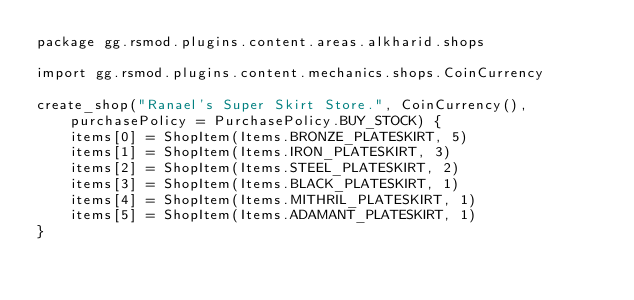<code> <loc_0><loc_0><loc_500><loc_500><_Kotlin_>package gg.rsmod.plugins.content.areas.alkharid.shops

import gg.rsmod.plugins.content.mechanics.shops.CoinCurrency

create_shop("Ranael's Super Skirt Store.", CoinCurrency(), purchasePolicy = PurchasePolicy.BUY_STOCK) {
    items[0] = ShopItem(Items.BRONZE_PLATESKIRT, 5)
    items[1] = ShopItem(Items.IRON_PLATESKIRT, 3)
    items[2] = ShopItem(Items.STEEL_PLATESKIRT, 2)
    items[3] = ShopItem(Items.BLACK_PLATESKIRT, 1)
    items[4] = ShopItem(Items.MITHRIL_PLATESKIRT, 1)
    items[5] = ShopItem(Items.ADAMANT_PLATESKIRT, 1)
}</code> 